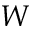<formula> <loc_0><loc_0><loc_500><loc_500>W</formula> 